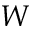<formula> <loc_0><loc_0><loc_500><loc_500>W</formula> 